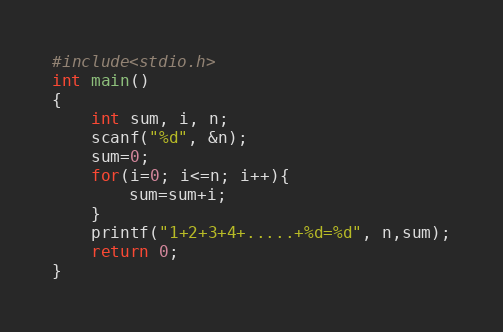Convert code to text. <code><loc_0><loc_0><loc_500><loc_500><_C_>#include<stdio.h>
int main()
{
    int sum, i, n;
    scanf("%d", &n);
    sum=0;
    for(i=0; i<=n; i++){
        sum=sum+i;
    }
    printf("1+2+3+4+.....+%d=%d", n,sum);
    return 0;
}</code> 